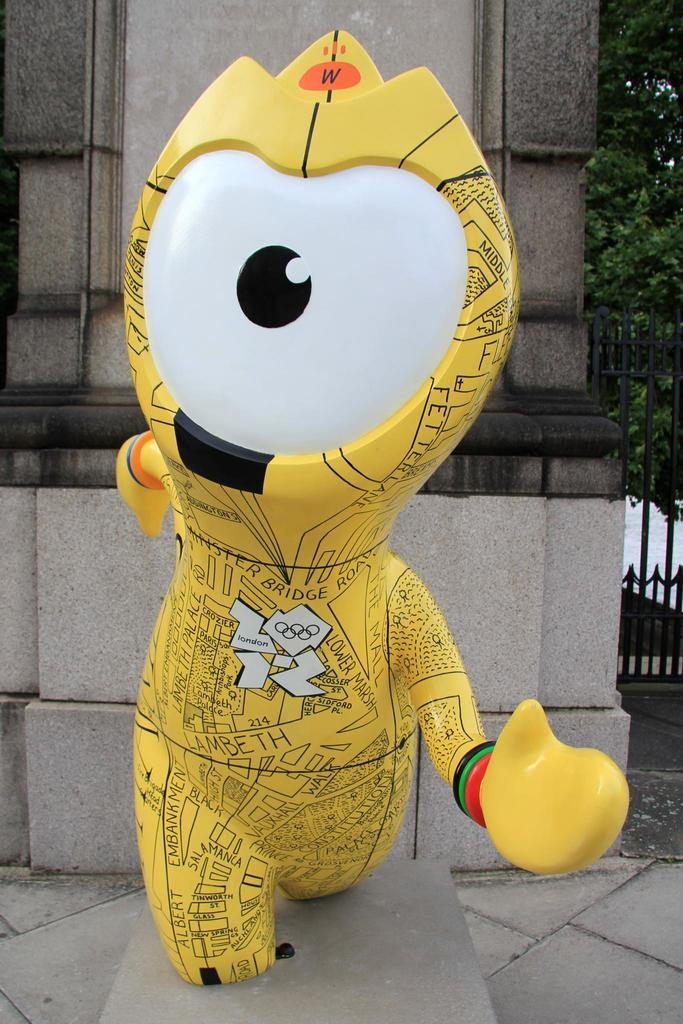What object can be seen on the floor in the image? There is a yellow balloon on the floor in the image. What is visible behind the balloon? In the background of the image, there is a wall, trees, and a gate. What color is the balloon? The balloon is yellow. Where is the balloon located in relation to the other elements in the image? The balloon is placed on the floor. What type of cork can be seen in the image? There is no cork present in the image. Is there a volcano visible in the background of the image? No, there is no volcano visible in the image. 